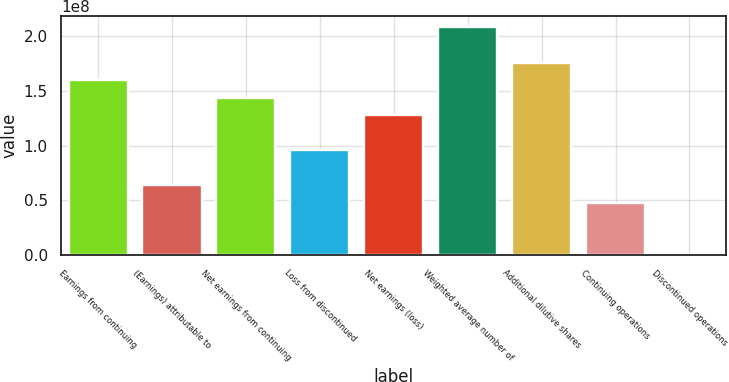<chart> <loc_0><loc_0><loc_500><loc_500><bar_chart><fcel>Earnings from continuing<fcel>(Earnings) attributable to<fcel>Net earnings from continuing<fcel>Loss from discontinued<fcel>Net earnings (loss)<fcel>Weighted average number of<fcel>Additional dilutive shares<fcel>Continuing operations<fcel>Discontinued operations<nl><fcel>1.59965e+08<fcel>6.39858e+07<fcel>1.43968e+08<fcel>9.59788e+07<fcel>1.27972e+08<fcel>2.07954e+08<fcel>1.75961e+08<fcel>4.79894e+07<fcel>0.04<nl></chart> 